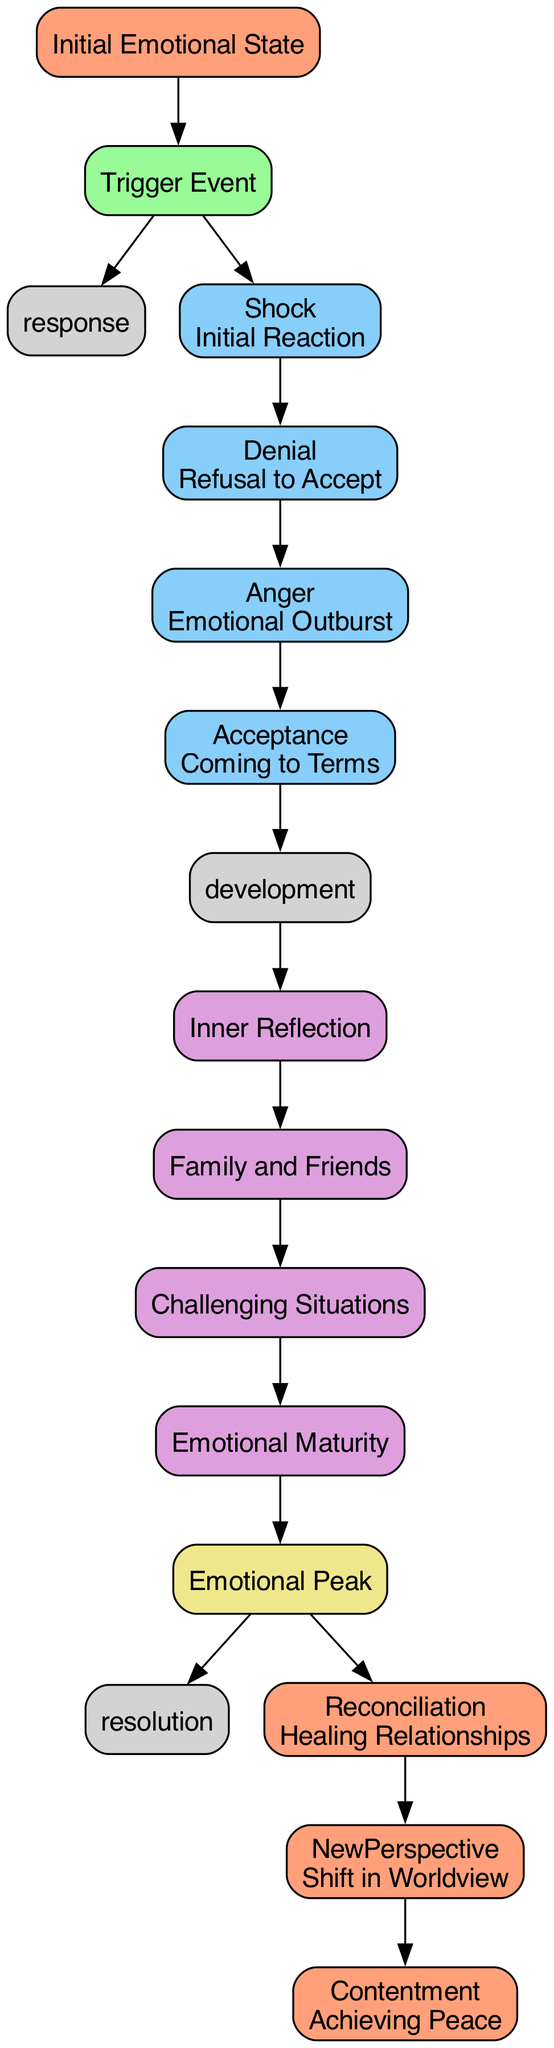What is the initial emotional state of the character? The starting point in the diagram clearly indicates that the character's initial emotional state is labeled as "Initial Emotional State."
Answer: Initial Emotional State How many emotional responses are listed in the diagram? By examining the Emotional Response cluster in the diagram, it can be seen that there are four distinct responses: Shock, Denial, Anger, and Acceptance, making the total count four.
Answer: 4 What follows after the emotional peak? In the diagram, from the Climax node labeled "Emotional Peak," it directs towards the Resolution, indicating that resolution follows the peak.
Answer: Resolution Which phase directly follows the emotional response phase? The flow of the diagram shows that after the Emotional Response phase, the next phase is the Development Phase, connecting through the edge marked 'development.'
Answer: Development Phase What is one form of external influence highlighted in the development phase? The diagram features an external influence categorized as 'Support System', which consists of family and friends, explicitly included in the Development Phase segment.
Answer: Support System How does the character reach emotional maturity? According to the diagram, the character reaches emotional maturity through the 'Growth' node in the Development Phase, indicating it is part of the journey towards maturity.
Answer: Growth What happens to relationships by the end of the emotional journey? The diagram illustrates that at the Resolution stage, one key aspect is 'Reconciliation,' which entails healing relationships, indicating a positive outcome for them.
Answer: Reconciliation In what format is the character's new perspective described in the resolution? The diagram specifies the 'New Perspective' in the Resolution phase, indicating a shift in the character's worldview is part of their evolution.
Answer: New Perspective What is the connecting phase between growth and climax? The diagram directly connects 'Growth' to the 'Climax' node, showing it is a crucial transitional phase in the emotional journey.
Answer: Climax 